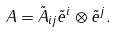<formula> <loc_0><loc_0><loc_500><loc_500>A = \tilde { A } _ { i j } \tilde { e } ^ { i } \otimes \tilde { e } ^ { j } .</formula> 